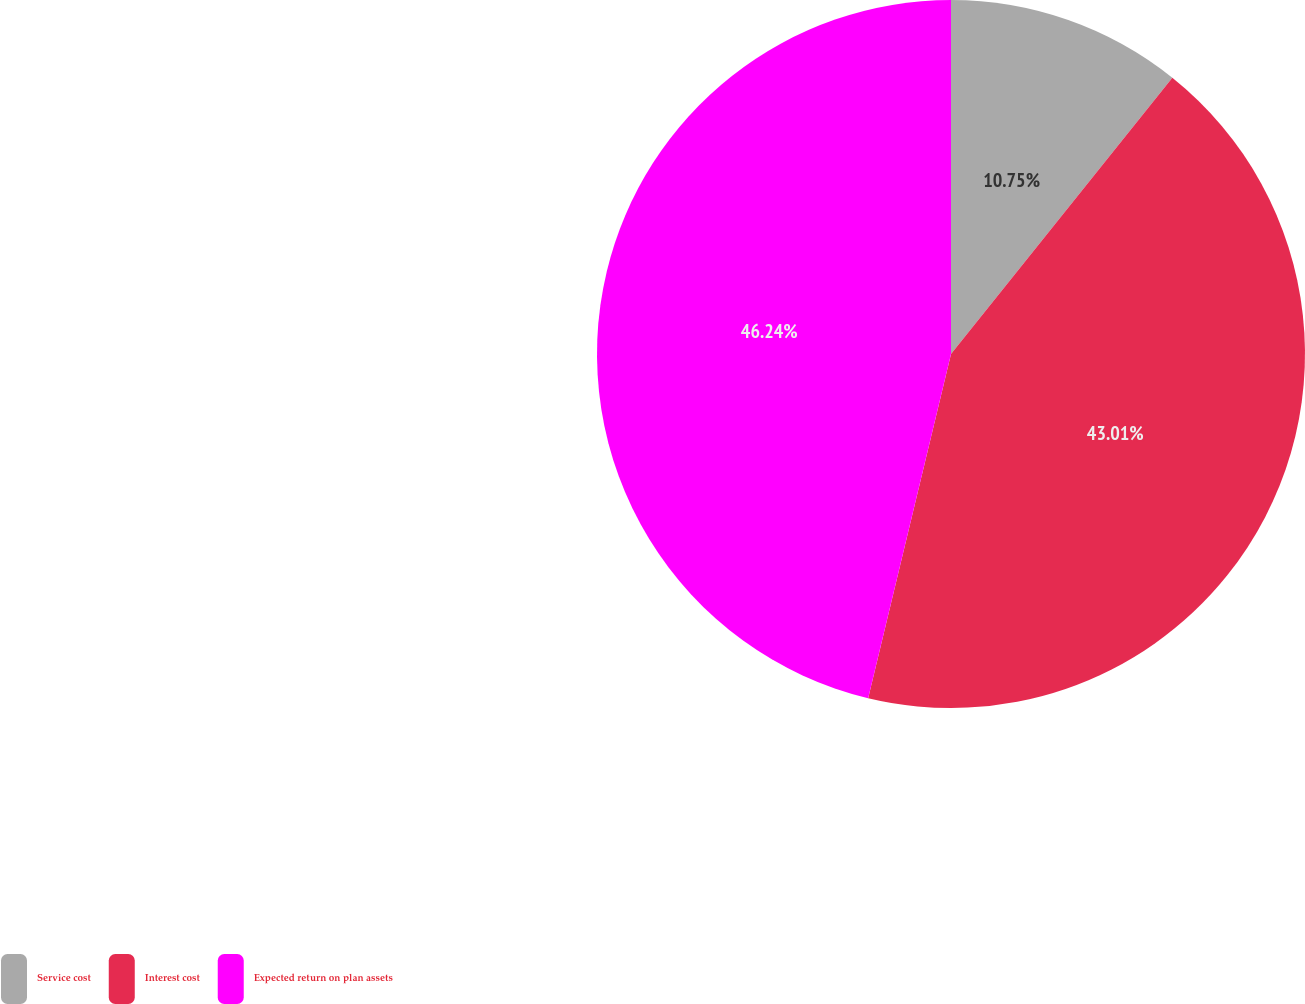Convert chart. <chart><loc_0><loc_0><loc_500><loc_500><pie_chart><fcel>Service cost<fcel>Interest cost<fcel>Expected return on plan assets<nl><fcel>10.75%<fcel>43.01%<fcel>46.24%<nl></chart> 